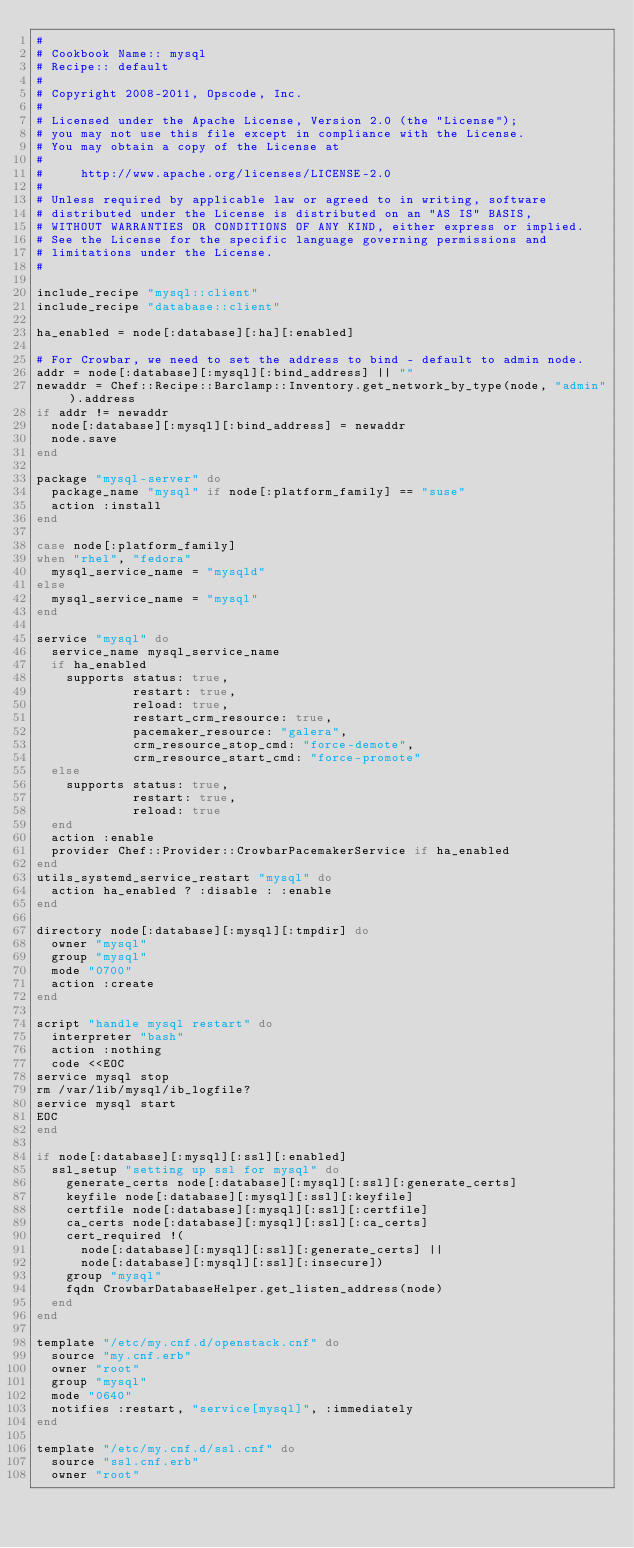<code> <loc_0><loc_0><loc_500><loc_500><_Ruby_>#
# Cookbook Name:: mysql
# Recipe:: default
#
# Copyright 2008-2011, Opscode, Inc.
#
# Licensed under the Apache License, Version 2.0 (the "License");
# you may not use this file except in compliance with the License.
# You may obtain a copy of the License at
#
#     http://www.apache.org/licenses/LICENSE-2.0
#
# Unless required by applicable law or agreed to in writing, software
# distributed under the License is distributed on an "AS IS" BASIS,
# WITHOUT WARRANTIES OR CONDITIONS OF ANY KIND, either express or implied.
# See the License for the specific language governing permissions and
# limitations under the License.
#

include_recipe "mysql::client"
include_recipe "database::client"

ha_enabled = node[:database][:ha][:enabled]

# For Crowbar, we need to set the address to bind - default to admin node.
addr = node[:database][:mysql][:bind_address] || ""
newaddr = Chef::Recipe::Barclamp::Inventory.get_network_by_type(node, "admin").address
if addr != newaddr
  node[:database][:mysql][:bind_address] = newaddr
  node.save
end

package "mysql-server" do
  package_name "mysql" if node[:platform_family] == "suse"
  action :install
end

case node[:platform_family]
when "rhel", "fedora"
  mysql_service_name = "mysqld"
else
  mysql_service_name = "mysql"
end

service "mysql" do
  service_name mysql_service_name
  if ha_enabled
    supports status: true,
             restart: true,
             reload: true,
             restart_crm_resource: true,
             pacemaker_resource: "galera",
             crm_resource_stop_cmd: "force-demote",
             crm_resource_start_cmd: "force-promote"
  else
    supports status: true,
             restart: true,
             reload: true
  end
  action :enable
  provider Chef::Provider::CrowbarPacemakerService if ha_enabled
end
utils_systemd_service_restart "mysql" do
  action ha_enabled ? :disable : :enable
end

directory node[:database][:mysql][:tmpdir] do
  owner "mysql"
  group "mysql"
  mode "0700"
  action :create
end

script "handle mysql restart" do
  interpreter "bash"
  action :nothing
  code <<EOC
service mysql stop
rm /var/lib/mysql/ib_logfile?
service mysql start
EOC
end

if node[:database][:mysql][:ssl][:enabled]
  ssl_setup "setting up ssl for mysql" do
    generate_certs node[:database][:mysql][:ssl][:generate_certs]
    keyfile node[:database][:mysql][:ssl][:keyfile]
    certfile node[:database][:mysql][:ssl][:certfile]
    ca_certs node[:database][:mysql][:ssl][:ca_certs]
    cert_required !(
      node[:database][:mysql][:ssl][:generate_certs] ||
      node[:database][:mysql][:ssl][:insecure])
    group "mysql"
    fqdn CrowbarDatabaseHelper.get_listen_address(node)
  end
end

template "/etc/my.cnf.d/openstack.cnf" do
  source "my.cnf.erb"
  owner "root"
  group "mysql"
  mode "0640"
  notifies :restart, "service[mysql]", :immediately
end

template "/etc/my.cnf.d/ssl.cnf" do
  source "ssl.cnf.erb"
  owner "root"</code> 